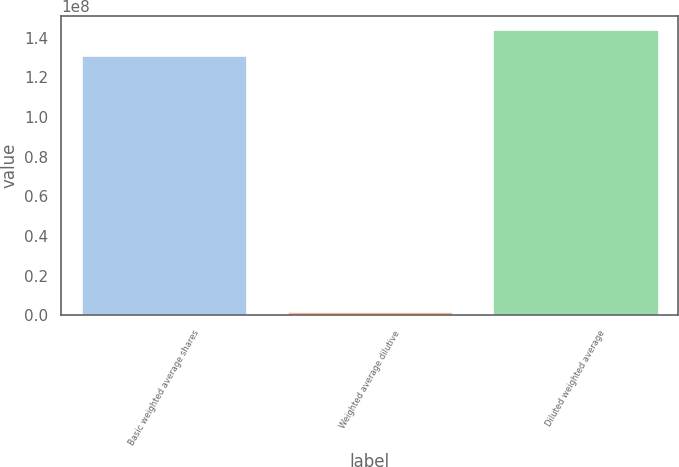Convert chart. <chart><loc_0><loc_0><loc_500><loc_500><bar_chart><fcel>Basic weighted average shares<fcel>Weighted average dilutive<fcel>Diluted weighted average<nl><fcel>1.30722e+08<fcel>1.91851e+06<fcel>1.43794e+08<nl></chart> 